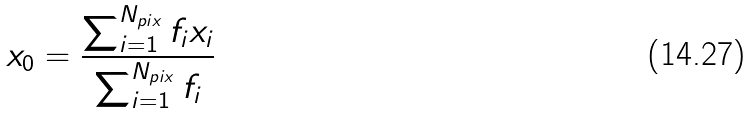Convert formula to latex. <formula><loc_0><loc_0><loc_500><loc_500>x _ { 0 } = \frac { \sum _ { i = 1 } ^ { N _ { p i x } } f _ { i } x _ { i } } { \sum _ { i = 1 } ^ { N _ { p i x } } f _ { i } }</formula> 